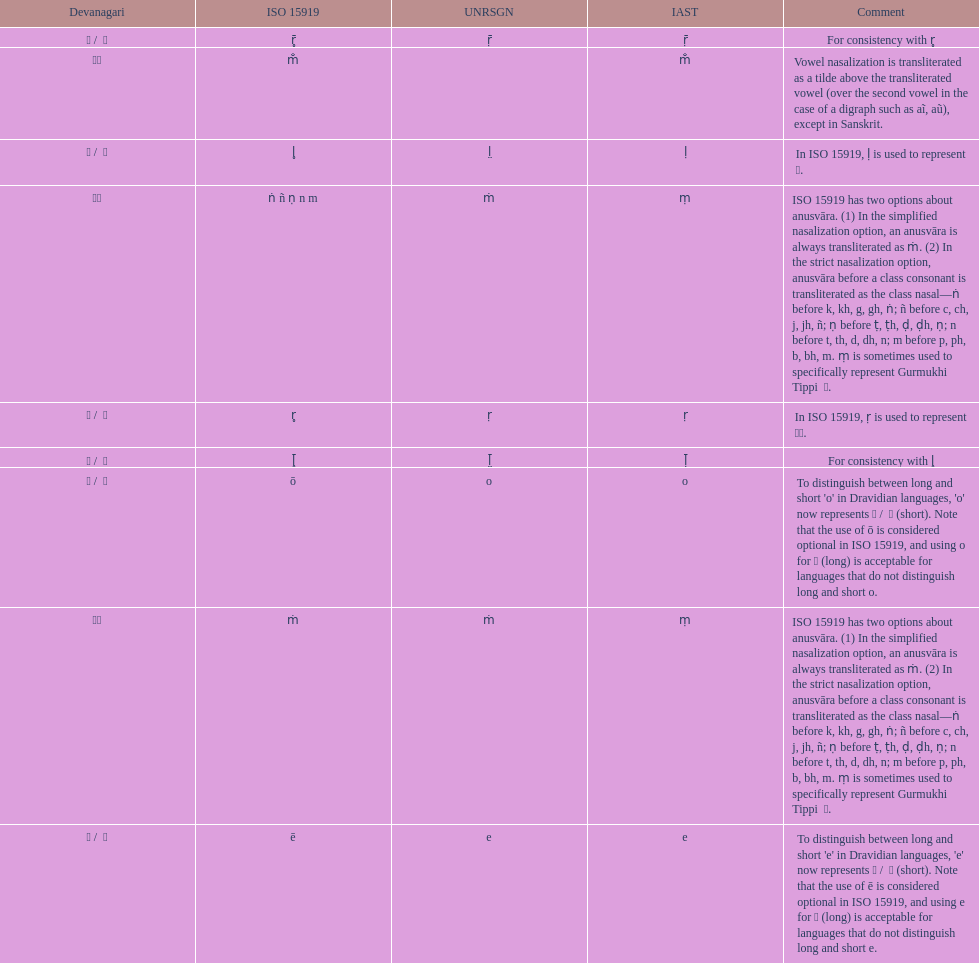This table shows the difference between how many transliterations? 3. 